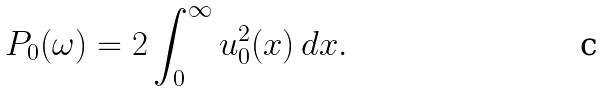<formula> <loc_0><loc_0><loc_500><loc_500>P _ { 0 } ( \omega ) = 2 \int _ { 0 } ^ { \infty } u _ { 0 } ^ { 2 } ( x ) \, d x .</formula> 